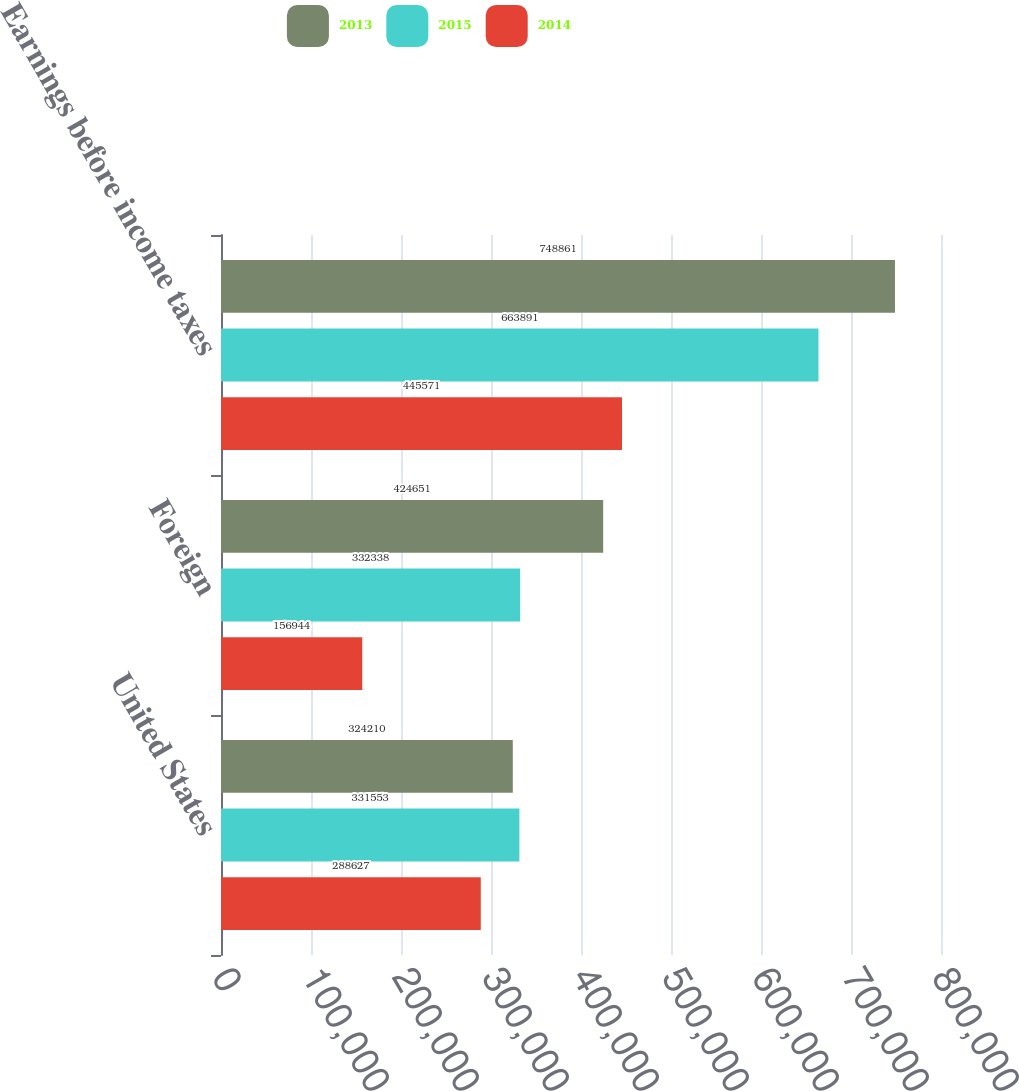Convert chart to OTSL. <chart><loc_0><loc_0><loc_500><loc_500><stacked_bar_chart><ecel><fcel>United States<fcel>Foreign<fcel>Earnings before income taxes<nl><fcel>2013<fcel>324210<fcel>424651<fcel>748861<nl><fcel>2015<fcel>331553<fcel>332338<fcel>663891<nl><fcel>2014<fcel>288627<fcel>156944<fcel>445571<nl></chart> 